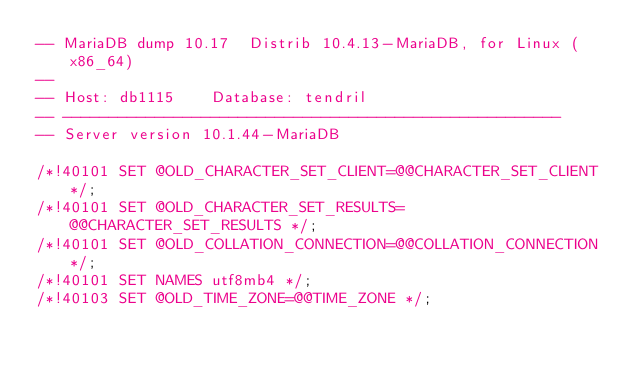Convert code to text. <code><loc_0><loc_0><loc_500><loc_500><_SQL_>-- MariaDB dump 10.17  Distrib 10.4.13-MariaDB, for Linux (x86_64)
--
-- Host: db1115    Database: tendril
-- ------------------------------------------------------
-- Server version	10.1.44-MariaDB

/*!40101 SET @OLD_CHARACTER_SET_CLIENT=@@CHARACTER_SET_CLIENT */;
/*!40101 SET @OLD_CHARACTER_SET_RESULTS=@@CHARACTER_SET_RESULTS */;
/*!40101 SET @OLD_COLLATION_CONNECTION=@@COLLATION_CONNECTION */;
/*!40101 SET NAMES utf8mb4 */;
/*!40103 SET @OLD_TIME_ZONE=@@TIME_ZONE */;</code> 